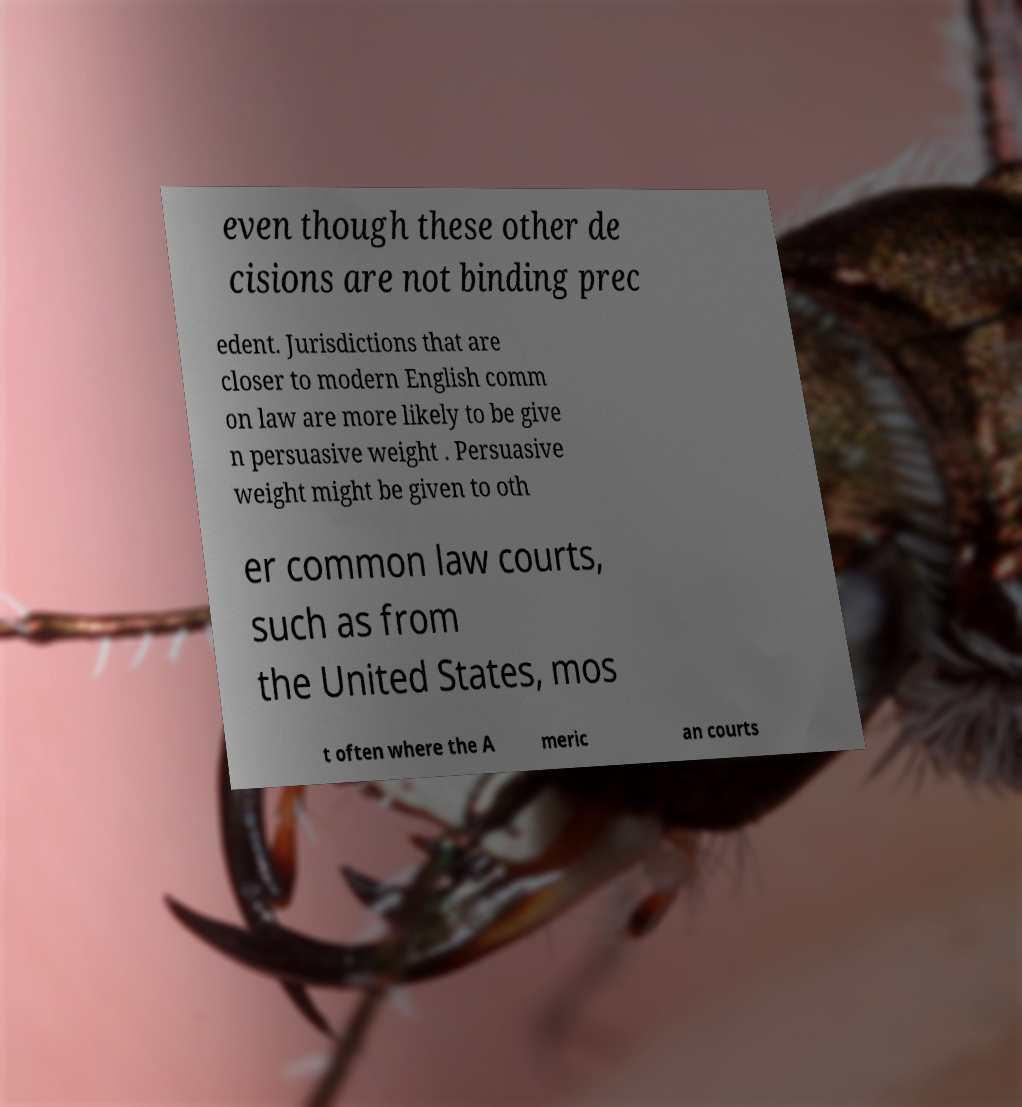Please read and relay the text visible in this image. What does it say? even though these other de cisions are not binding prec edent. Jurisdictions that are closer to modern English comm on law are more likely to be give n persuasive weight . Persuasive weight might be given to oth er common law courts, such as from the United States, mos t often where the A meric an courts 